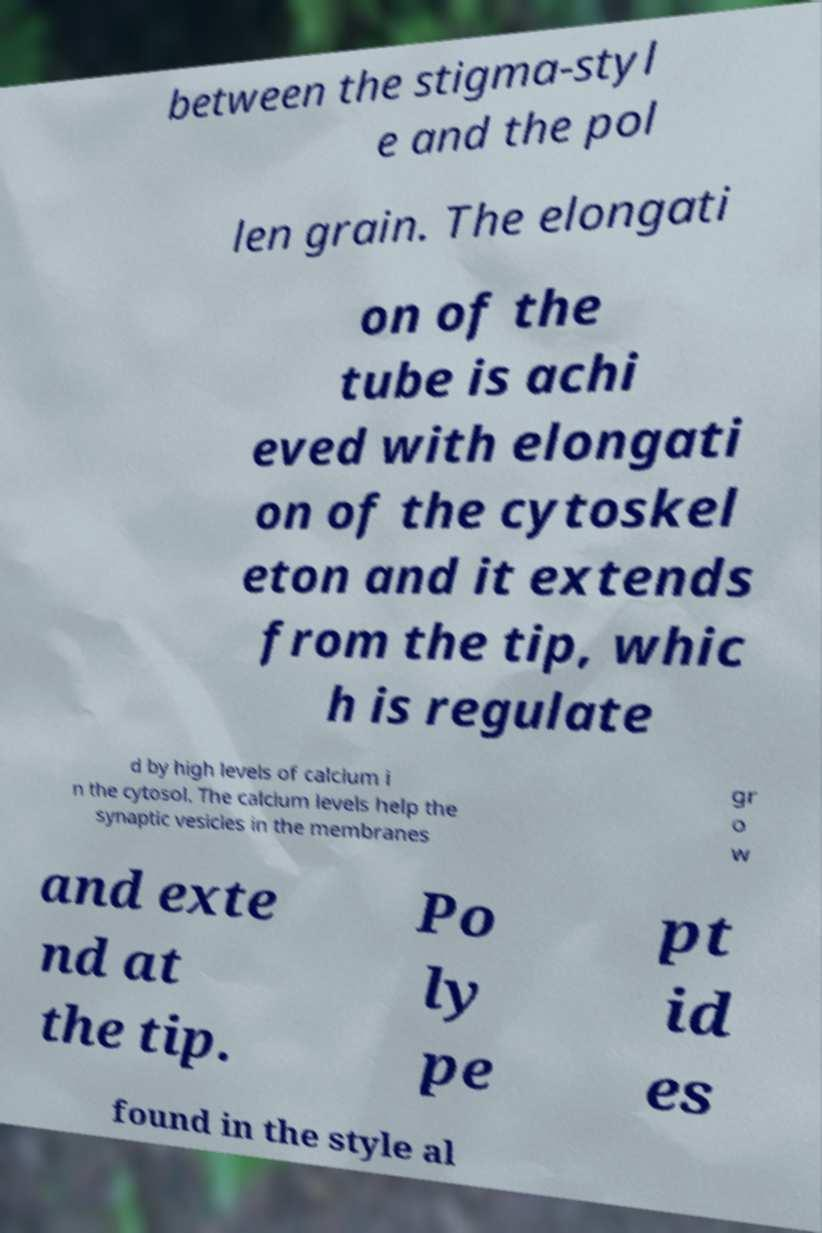Could you assist in decoding the text presented in this image and type it out clearly? between the stigma-styl e and the pol len grain. The elongati on of the tube is achi eved with elongati on of the cytoskel eton and it extends from the tip, whic h is regulate d by high levels of calcium i n the cytosol. The calcium levels help the synaptic vesicles in the membranes gr o w and exte nd at the tip. Po ly pe pt id es found in the style al 